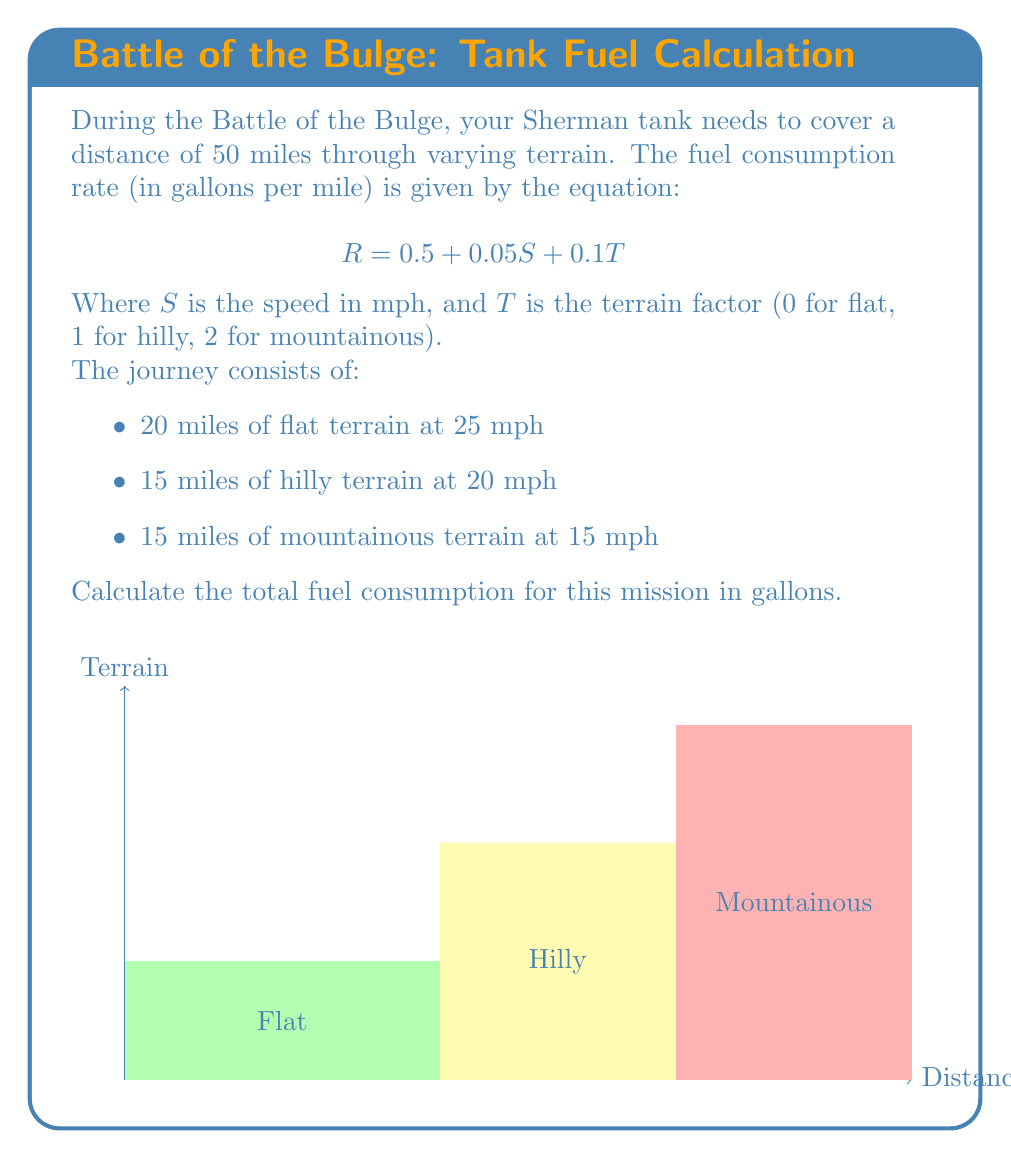Could you help me with this problem? Let's solve this problem step by step:

1) First, we need to calculate the fuel consumption rate for each terrain type:

   For flat terrain: $R_1 = 0.5 + 0.05(25) + 0.1(0) = 1.75$ gal/mile
   For hilly terrain: $R_2 = 0.5 + 0.05(20) + 0.1(1) = 1.6$ gal/mile
   For mountainous terrain: $R_3 = 0.5 + 0.05(15) + 0.1(2) = 1.45$ gal/mile

2) Now, we calculate the fuel consumption for each segment:

   Flat terrain: $20 \text{ miles} \times 1.75 \text{ gal/mile} = 35$ gallons
   Hilly terrain: $15 \text{ miles} \times 1.6 \text{ gal/mile} = 24$ gallons
   Mountainous terrain: $15 \text{ miles} \times 1.45 \text{ gal/mile} = 21.75$ gallons

3) Finally, we sum up the fuel consumption for all segments:

   Total fuel consumption = $35 + 24 + 21.75 = 80.75$ gallons
Answer: 80.75 gallons 